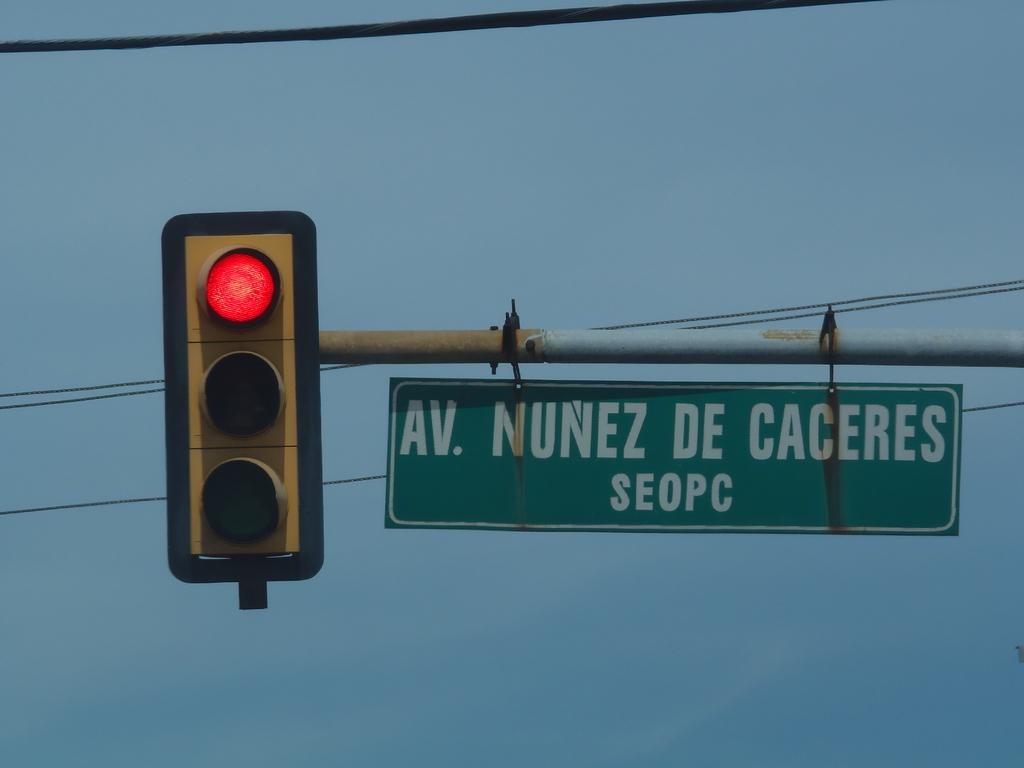What street is this?
Your answer should be compact. Av. nunez de caceres. 